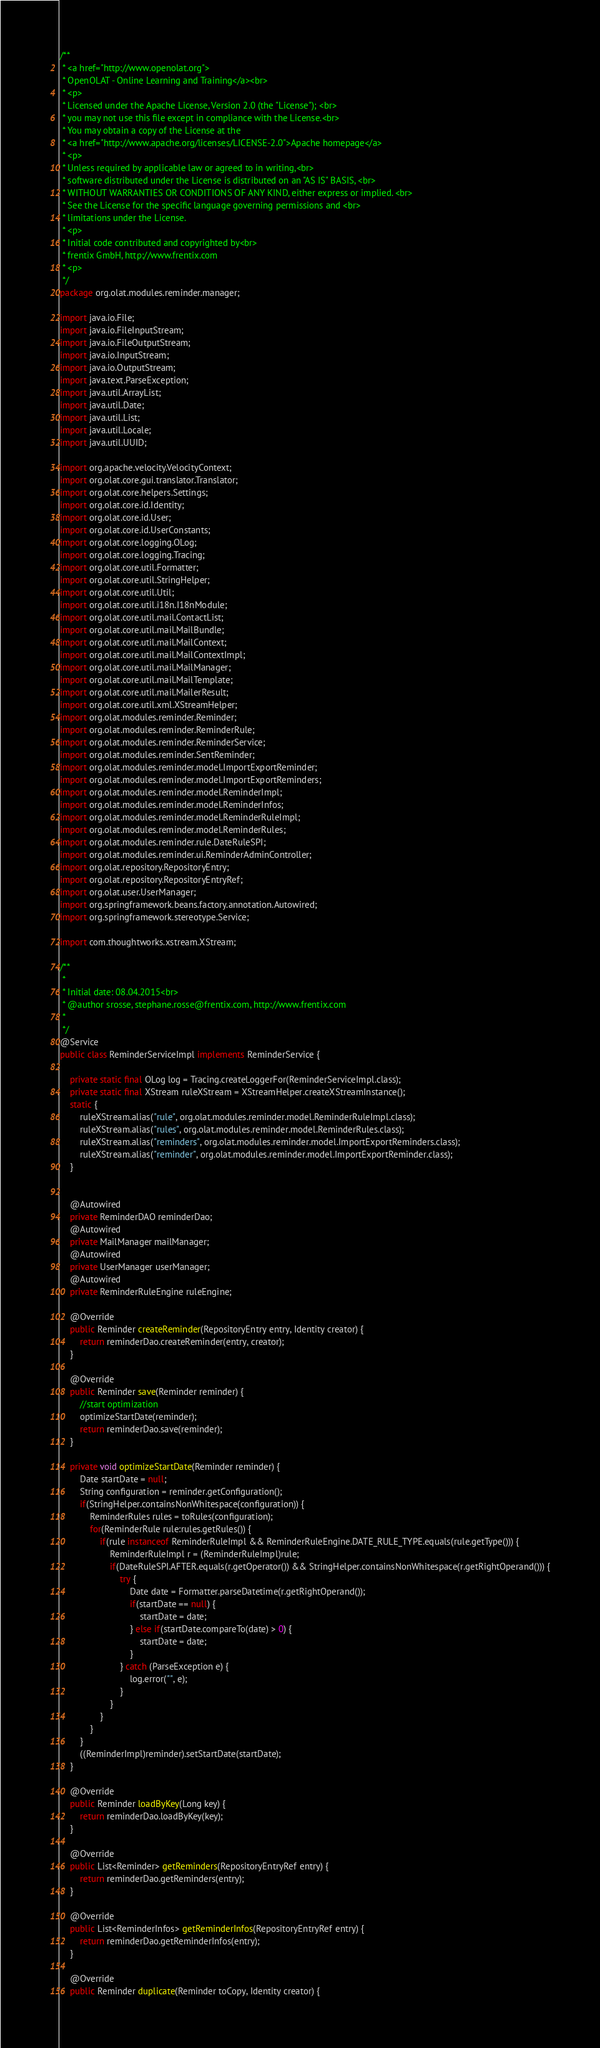<code> <loc_0><loc_0><loc_500><loc_500><_Java_>/**
 * <a href="http://www.openolat.org">
 * OpenOLAT - Online Learning and Training</a><br>
 * <p>
 * Licensed under the Apache License, Version 2.0 (the "License"); <br>
 * you may not use this file except in compliance with the License.<br>
 * You may obtain a copy of the License at the
 * <a href="http://www.apache.org/licenses/LICENSE-2.0">Apache homepage</a>
 * <p>
 * Unless required by applicable law or agreed to in writing,<br>
 * software distributed under the License is distributed on an "AS IS" BASIS, <br>
 * WITHOUT WARRANTIES OR CONDITIONS OF ANY KIND, either express or implied. <br>
 * See the License for the specific language governing permissions and <br>
 * limitations under the License.
 * <p>
 * Initial code contributed and copyrighted by<br>
 * frentix GmbH, http://www.frentix.com
 * <p>
 */
package org.olat.modules.reminder.manager;

import java.io.File;
import java.io.FileInputStream;
import java.io.FileOutputStream;
import java.io.InputStream;
import java.io.OutputStream;
import java.text.ParseException;
import java.util.ArrayList;
import java.util.Date;
import java.util.List;
import java.util.Locale;
import java.util.UUID;

import org.apache.velocity.VelocityContext;
import org.olat.core.gui.translator.Translator;
import org.olat.core.helpers.Settings;
import org.olat.core.id.Identity;
import org.olat.core.id.User;
import org.olat.core.id.UserConstants;
import org.olat.core.logging.OLog;
import org.olat.core.logging.Tracing;
import org.olat.core.util.Formatter;
import org.olat.core.util.StringHelper;
import org.olat.core.util.Util;
import org.olat.core.util.i18n.I18nModule;
import org.olat.core.util.mail.ContactList;
import org.olat.core.util.mail.MailBundle;
import org.olat.core.util.mail.MailContext;
import org.olat.core.util.mail.MailContextImpl;
import org.olat.core.util.mail.MailManager;
import org.olat.core.util.mail.MailTemplate;
import org.olat.core.util.mail.MailerResult;
import org.olat.core.util.xml.XStreamHelper;
import org.olat.modules.reminder.Reminder;
import org.olat.modules.reminder.ReminderRule;
import org.olat.modules.reminder.ReminderService;
import org.olat.modules.reminder.SentReminder;
import org.olat.modules.reminder.model.ImportExportReminder;
import org.olat.modules.reminder.model.ImportExportReminders;
import org.olat.modules.reminder.model.ReminderImpl;
import org.olat.modules.reminder.model.ReminderInfos;
import org.olat.modules.reminder.model.ReminderRuleImpl;
import org.olat.modules.reminder.model.ReminderRules;
import org.olat.modules.reminder.rule.DateRuleSPI;
import org.olat.modules.reminder.ui.ReminderAdminController;
import org.olat.repository.RepositoryEntry;
import org.olat.repository.RepositoryEntryRef;
import org.olat.user.UserManager;
import org.springframework.beans.factory.annotation.Autowired;
import org.springframework.stereotype.Service;

import com.thoughtworks.xstream.XStream;

/**
 * 
 * Initial date: 08.04.2015<br>
 * @author srosse, stephane.rosse@frentix.com, http://www.frentix.com
 *
 */
@Service
public class ReminderServiceImpl implements ReminderService {
	
	private static final OLog log = Tracing.createLoggerFor(ReminderServiceImpl.class);
	private static final XStream ruleXStream = XStreamHelper.createXStreamInstance();
	static {
		ruleXStream.alias("rule", org.olat.modules.reminder.model.ReminderRuleImpl.class);
		ruleXStream.alias("rules", org.olat.modules.reminder.model.ReminderRules.class);
		ruleXStream.alias("reminders", org.olat.modules.reminder.model.ImportExportReminders.class);
		ruleXStream.alias("reminder", org.olat.modules.reminder.model.ImportExportReminder.class);
	}
	
	
	@Autowired
	private ReminderDAO reminderDao;
	@Autowired
	private MailManager mailManager;
	@Autowired
	private UserManager userManager;
	@Autowired
	private ReminderRuleEngine ruleEngine;
	
	@Override
	public Reminder createReminder(RepositoryEntry entry, Identity creator) {
		return reminderDao.createReminder(entry, creator);
	}
	
	@Override
	public Reminder save(Reminder reminder) {
		//start optimization
		optimizeStartDate(reminder);
		return reminderDao.save(reminder);
	}
	
	private void optimizeStartDate(Reminder reminder) {
		Date startDate = null;
		String configuration = reminder.getConfiguration();
		if(StringHelper.containsNonWhitespace(configuration)) {
			ReminderRules rules = toRules(configuration);
			for(ReminderRule rule:rules.getRules()) {
				if(rule instanceof ReminderRuleImpl && ReminderRuleEngine.DATE_RULE_TYPE.equals(rule.getType())) {
					ReminderRuleImpl r = (ReminderRuleImpl)rule;
					if(DateRuleSPI.AFTER.equals(r.getOperator()) && StringHelper.containsNonWhitespace(r.getRightOperand())) {
						try {
							Date date = Formatter.parseDatetime(r.getRightOperand());
							if(startDate == null) {
								startDate = date;
							} else if(startDate.compareTo(date) > 0) {
								startDate = date;
							}
						} catch (ParseException e) {
							log.error("", e);
						}
					}
				}
			}
		}		
		((ReminderImpl)reminder).setStartDate(startDate);
	}
	
	@Override
	public Reminder loadByKey(Long key) {
		return reminderDao.loadByKey(key);
	}
	
	@Override
	public List<Reminder> getReminders(RepositoryEntryRef entry) {
		return reminderDao.getReminders(entry);
	}

	@Override
	public List<ReminderInfos> getReminderInfos(RepositoryEntryRef entry) {
		return reminderDao.getReminderInfos(entry);
	}
	
	@Override
	public Reminder duplicate(Reminder toCopy, Identity creator) {</code> 